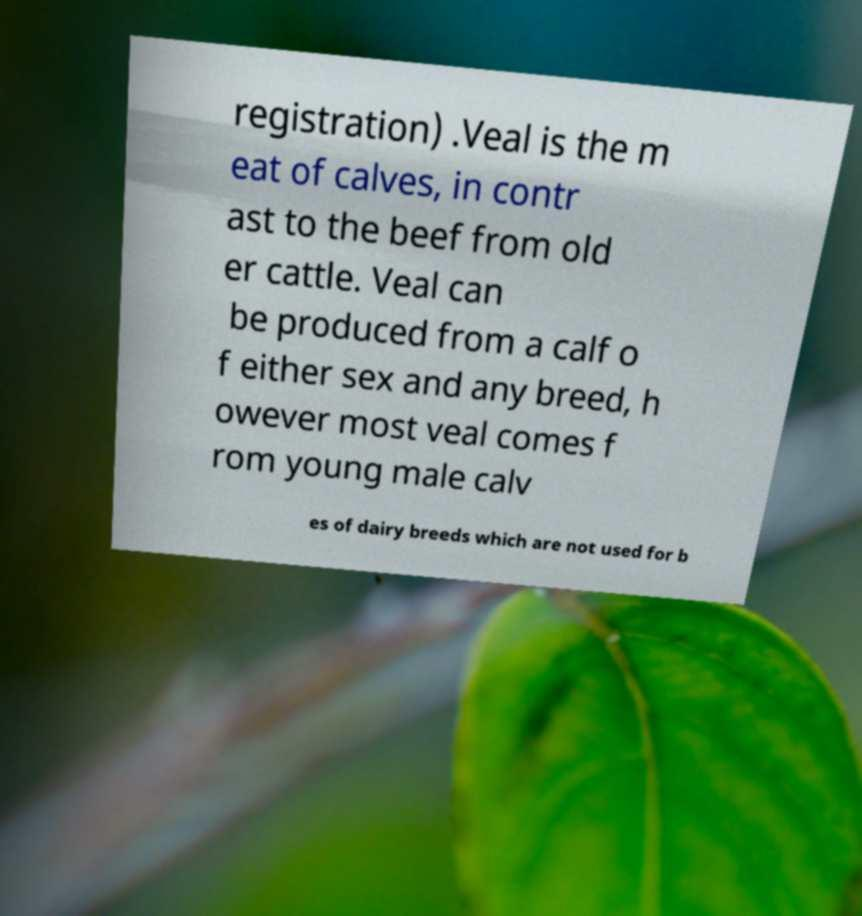Please read and relay the text visible in this image. What does it say? registration) .Veal is the m eat of calves, in contr ast to the beef from old er cattle. Veal can be produced from a calf o f either sex and any breed, h owever most veal comes f rom young male calv es of dairy breeds which are not used for b 